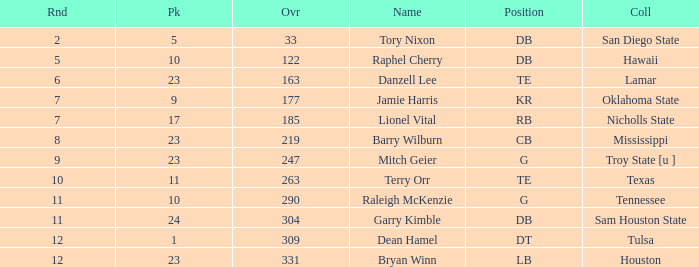Which Round is the highest one that has a Pick smaller than 10, and a Name of tory nixon? 2.0. 